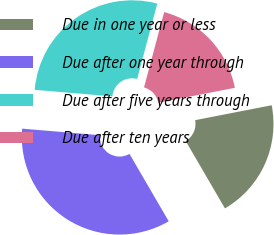<chart> <loc_0><loc_0><loc_500><loc_500><pie_chart><fcel>Due in one year or less<fcel>Due after one year through<fcel>Due after five years through<fcel>Due after ten years<nl><fcel>19.67%<fcel>34.73%<fcel>27.82%<fcel>17.78%<nl></chart> 